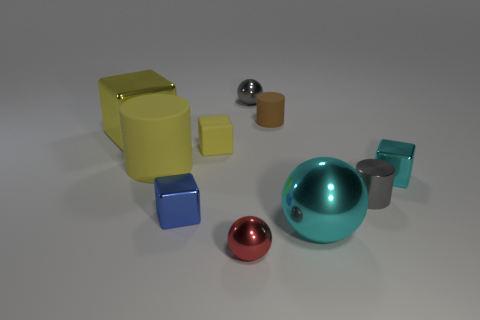Is the material of the big cyan ball the same as the big yellow cylinder?
Ensure brevity in your answer.  No. The big metallic object that is the same shape as the small yellow thing is what color?
Provide a short and direct response. Yellow. There is a block that is in front of the tiny cyan block; does it have the same color as the big sphere?
Make the answer very short. No. What is the shape of the big rubber object that is the same color as the rubber block?
Offer a very short reply. Cylinder. How many cyan balls are made of the same material as the small gray ball?
Provide a succinct answer. 1. How many gray spheres are behind the large matte object?
Your response must be concise. 1. What is the size of the gray metallic ball?
Offer a very short reply. Small. The metallic sphere that is the same size as the red metallic thing is what color?
Offer a terse response. Gray. Is there a tiny cylinder of the same color as the big matte cylinder?
Ensure brevity in your answer.  No. What is the material of the yellow cylinder?
Make the answer very short. Rubber. 